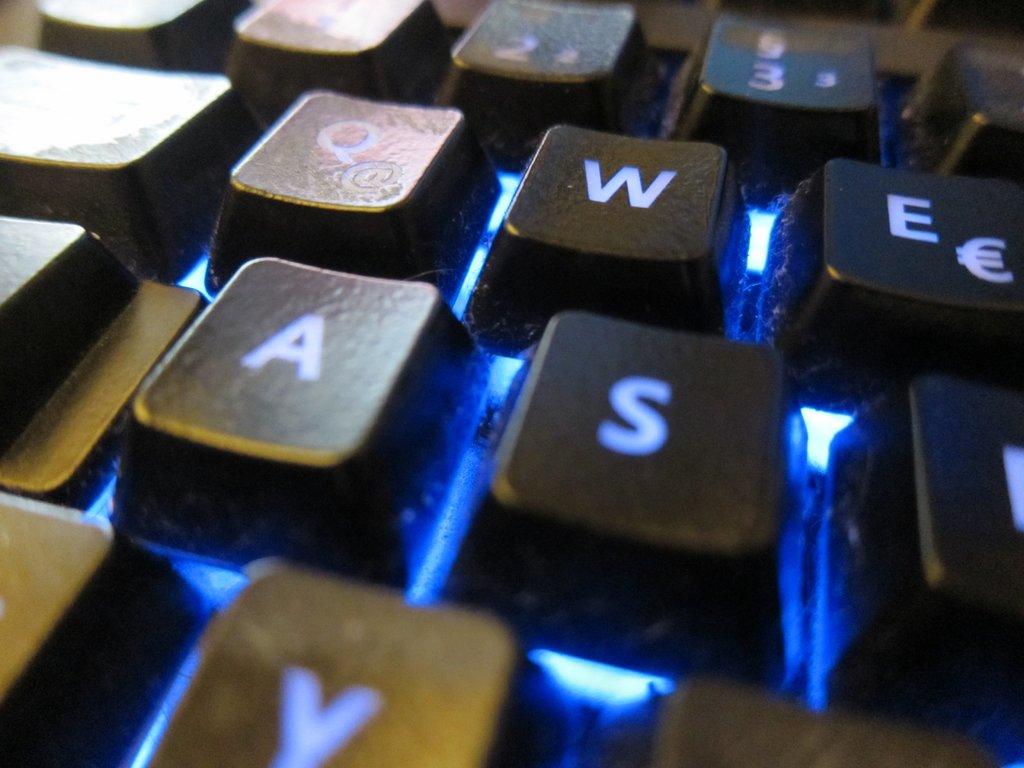What is on the key in the right center?
Keep it short and to the point. S. What key also has an @ sign on it?
Provide a succinct answer. Q. 